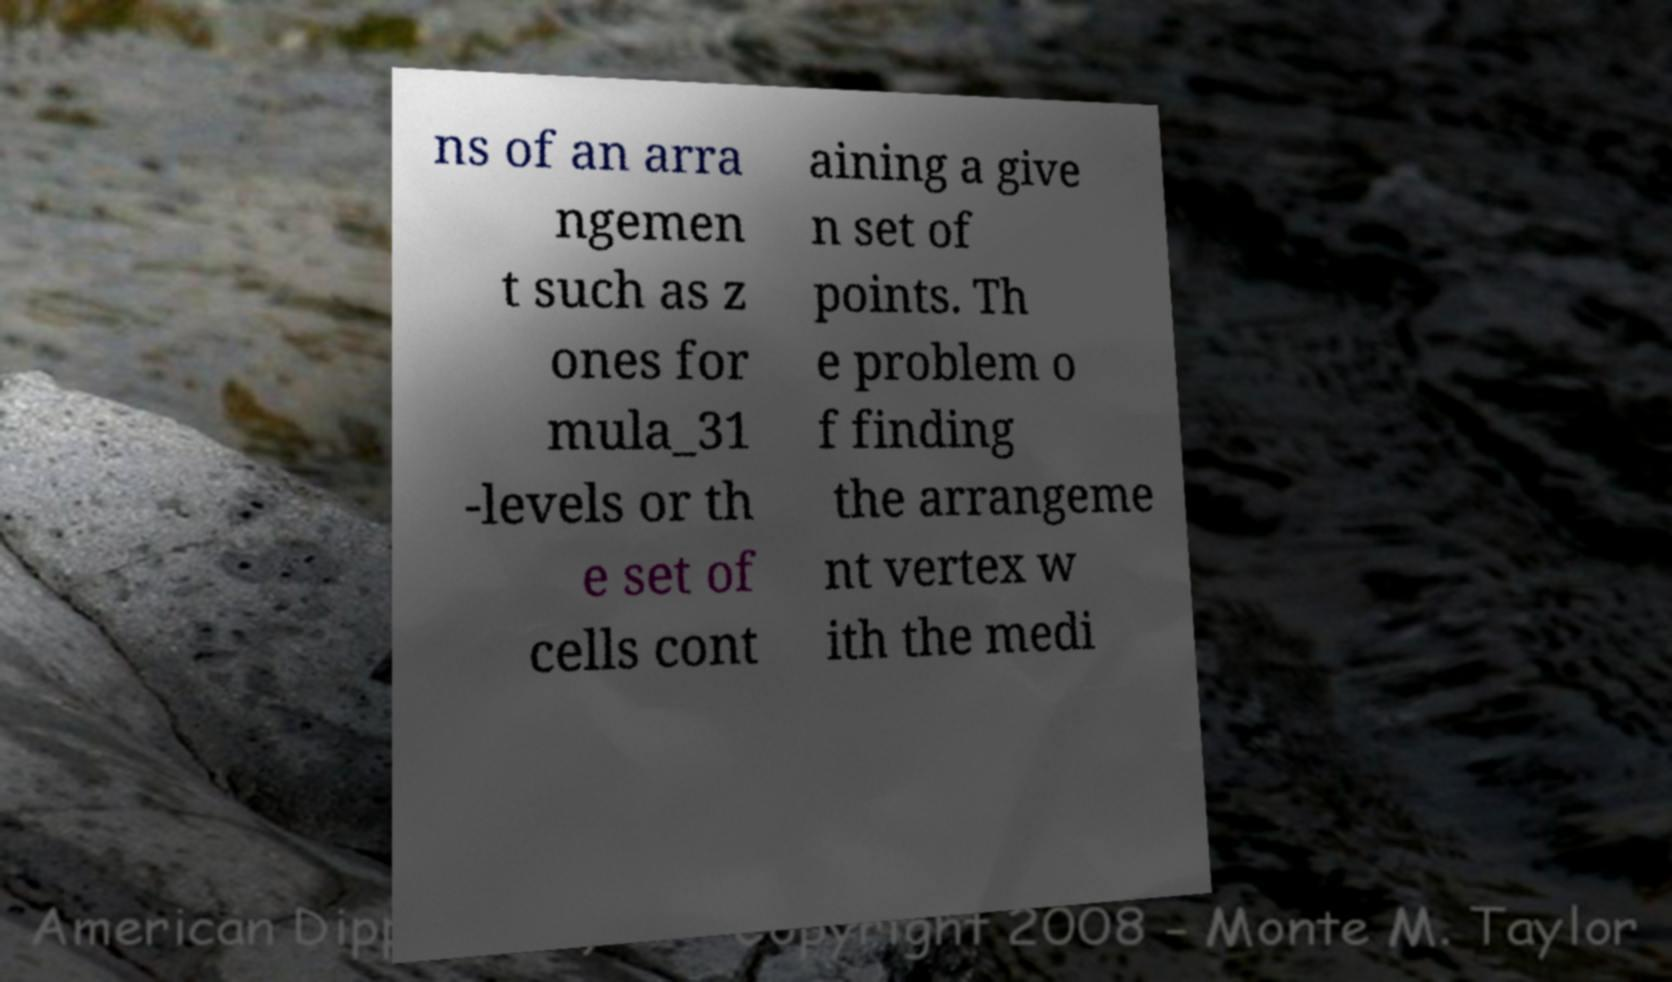Could you assist in decoding the text presented in this image and type it out clearly? ns of an arra ngemen t such as z ones for mula_31 -levels or th e set of cells cont aining a give n set of points. Th e problem o f finding the arrangeme nt vertex w ith the medi 